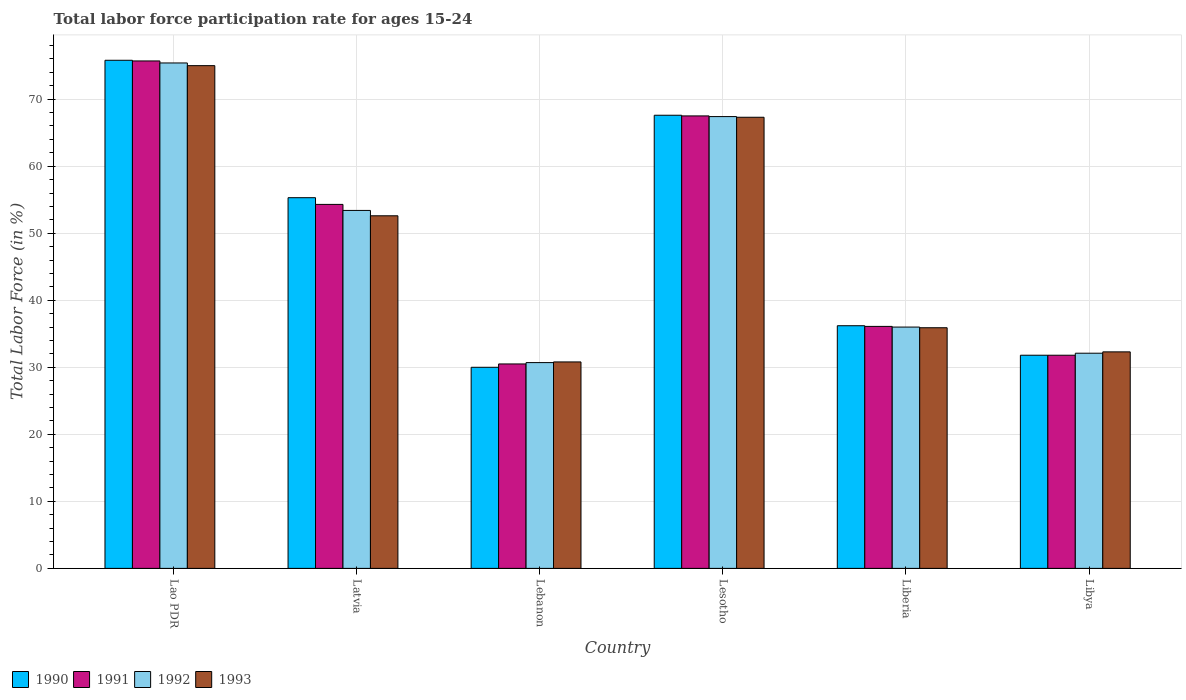Are the number of bars on each tick of the X-axis equal?
Keep it short and to the point. Yes. What is the label of the 6th group of bars from the left?
Offer a terse response. Libya. What is the labor force participation rate in 1992 in Lao PDR?
Give a very brief answer. 75.4. Across all countries, what is the maximum labor force participation rate in 1992?
Give a very brief answer. 75.4. Across all countries, what is the minimum labor force participation rate in 1993?
Give a very brief answer. 30.8. In which country was the labor force participation rate in 1992 maximum?
Keep it short and to the point. Lao PDR. In which country was the labor force participation rate in 1992 minimum?
Offer a very short reply. Lebanon. What is the total labor force participation rate in 1992 in the graph?
Offer a very short reply. 295. What is the difference between the labor force participation rate in 1993 in Lebanon and that in Liberia?
Ensure brevity in your answer.  -5.1. What is the difference between the labor force participation rate in 1993 in Lao PDR and the labor force participation rate in 1990 in Liberia?
Make the answer very short. 38.8. What is the average labor force participation rate in 1993 per country?
Your answer should be compact. 48.98. What is the difference between the labor force participation rate of/in 1992 and labor force participation rate of/in 1991 in Libya?
Your response must be concise. 0.3. What is the ratio of the labor force participation rate in 1991 in Lebanon to that in Liberia?
Your answer should be compact. 0.84. What is the difference between the highest and the second highest labor force participation rate in 1991?
Keep it short and to the point. -8.2. What is the difference between the highest and the lowest labor force participation rate in 1992?
Keep it short and to the point. 44.7. Is the sum of the labor force participation rate in 1992 in Lebanon and Liberia greater than the maximum labor force participation rate in 1993 across all countries?
Offer a very short reply. No. Is it the case that in every country, the sum of the labor force participation rate in 1990 and labor force participation rate in 1992 is greater than the sum of labor force participation rate in 1993 and labor force participation rate in 1991?
Ensure brevity in your answer.  No. What does the 4th bar from the left in Lesotho represents?
Give a very brief answer. 1993. Is it the case that in every country, the sum of the labor force participation rate in 1992 and labor force participation rate in 1991 is greater than the labor force participation rate in 1993?
Ensure brevity in your answer.  Yes. How many bars are there?
Offer a very short reply. 24. How many countries are there in the graph?
Offer a terse response. 6. Does the graph contain any zero values?
Keep it short and to the point. No. Where does the legend appear in the graph?
Your answer should be compact. Bottom left. How are the legend labels stacked?
Give a very brief answer. Horizontal. What is the title of the graph?
Your answer should be very brief. Total labor force participation rate for ages 15-24. What is the Total Labor Force (in %) in 1990 in Lao PDR?
Give a very brief answer. 75.8. What is the Total Labor Force (in %) in 1991 in Lao PDR?
Your response must be concise. 75.7. What is the Total Labor Force (in %) in 1992 in Lao PDR?
Offer a terse response. 75.4. What is the Total Labor Force (in %) in 1993 in Lao PDR?
Your answer should be compact. 75. What is the Total Labor Force (in %) of 1990 in Latvia?
Your response must be concise. 55.3. What is the Total Labor Force (in %) of 1991 in Latvia?
Your response must be concise. 54.3. What is the Total Labor Force (in %) in 1992 in Latvia?
Give a very brief answer. 53.4. What is the Total Labor Force (in %) of 1993 in Latvia?
Ensure brevity in your answer.  52.6. What is the Total Labor Force (in %) of 1991 in Lebanon?
Your answer should be very brief. 30.5. What is the Total Labor Force (in %) in 1992 in Lebanon?
Give a very brief answer. 30.7. What is the Total Labor Force (in %) in 1993 in Lebanon?
Ensure brevity in your answer.  30.8. What is the Total Labor Force (in %) in 1990 in Lesotho?
Provide a succinct answer. 67.6. What is the Total Labor Force (in %) of 1991 in Lesotho?
Your response must be concise. 67.5. What is the Total Labor Force (in %) in 1992 in Lesotho?
Ensure brevity in your answer.  67.4. What is the Total Labor Force (in %) of 1993 in Lesotho?
Offer a very short reply. 67.3. What is the Total Labor Force (in %) of 1990 in Liberia?
Provide a succinct answer. 36.2. What is the Total Labor Force (in %) in 1991 in Liberia?
Ensure brevity in your answer.  36.1. What is the Total Labor Force (in %) in 1993 in Liberia?
Ensure brevity in your answer.  35.9. What is the Total Labor Force (in %) in 1990 in Libya?
Keep it short and to the point. 31.8. What is the Total Labor Force (in %) of 1991 in Libya?
Provide a short and direct response. 31.8. What is the Total Labor Force (in %) of 1992 in Libya?
Provide a short and direct response. 32.1. What is the Total Labor Force (in %) in 1993 in Libya?
Your answer should be compact. 32.3. Across all countries, what is the maximum Total Labor Force (in %) in 1990?
Give a very brief answer. 75.8. Across all countries, what is the maximum Total Labor Force (in %) of 1991?
Provide a short and direct response. 75.7. Across all countries, what is the maximum Total Labor Force (in %) of 1992?
Your answer should be compact. 75.4. Across all countries, what is the minimum Total Labor Force (in %) of 1990?
Keep it short and to the point. 30. Across all countries, what is the minimum Total Labor Force (in %) of 1991?
Your answer should be compact. 30.5. Across all countries, what is the minimum Total Labor Force (in %) in 1992?
Your answer should be very brief. 30.7. Across all countries, what is the minimum Total Labor Force (in %) of 1993?
Provide a succinct answer. 30.8. What is the total Total Labor Force (in %) of 1990 in the graph?
Ensure brevity in your answer.  296.7. What is the total Total Labor Force (in %) in 1991 in the graph?
Keep it short and to the point. 295.9. What is the total Total Labor Force (in %) of 1992 in the graph?
Keep it short and to the point. 295. What is the total Total Labor Force (in %) in 1993 in the graph?
Your response must be concise. 293.9. What is the difference between the Total Labor Force (in %) in 1991 in Lao PDR and that in Latvia?
Offer a terse response. 21.4. What is the difference between the Total Labor Force (in %) in 1993 in Lao PDR and that in Latvia?
Ensure brevity in your answer.  22.4. What is the difference between the Total Labor Force (in %) of 1990 in Lao PDR and that in Lebanon?
Your response must be concise. 45.8. What is the difference between the Total Labor Force (in %) in 1991 in Lao PDR and that in Lebanon?
Ensure brevity in your answer.  45.2. What is the difference between the Total Labor Force (in %) in 1992 in Lao PDR and that in Lebanon?
Give a very brief answer. 44.7. What is the difference between the Total Labor Force (in %) of 1993 in Lao PDR and that in Lebanon?
Give a very brief answer. 44.2. What is the difference between the Total Labor Force (in %) in 1990 in Lao PDR and that in Lesotho?
Offer a very short reply. 8.2. What is the difference between the Total Labor Force (in %) in 1991 in Lao PDR and that in Lesotho?
Keep it short and to the point. 8.2. What is the difference between the Total Labor Force (in %) of 1992 in Lao PDR and that in Lesotho?
Your answer should be very brief. 8. What is the difference between the Total Labor Force (in %) in 1993 in Lao PDR and that in Lesotho?
Offer a terse response. 7.7. What is the difference between the Total Labor Force (in %) of 1990 in Lao PDR and that in Liberia?
Provide a short and direct response. 39.6. What is the difference between the Total Labor Force (in %) in 1991 in Lao PDR and that in Liberia?
Provide a short and direct response. 39.6. What is the difference between the Total Labor Force (in %) of 1992 in Lao PDR and that in Liberia?
Your response must be concise. 39.4. What is the difference between the Total Labor Force (in %) of 1993 in Lao PDR and that in Liberia?
Offer a very short reply. 39.1. What is the difference between the Total Labor Force (in %) of 1991 in Lao PDR and that in Libya?
Your answer should be compact. 43.9. What is the difference between the Total Labor Force (in %) of 1992 in Lao PDR and that in Libya?
Provide a short and direct response. 43.3. What is the difference between the Total Labor Force (in %) in 1993 in Lao PDR and that in Libya?
Provide a succinct answer. 42.7. What is the difference between the Total Labor Force (in %) of 1990 in Latvia and that in Lebanon?
Your answer should be very brief. 25.3. What is the difference between the Total Labor Force (in %) of 1991 in Latvia and that in Lebanon?
Give a very brief answer. 23.8. What is the difference between the Total Labor Force (in %) in 1992 in Latvia and that in Lebanon?
Provide a short and direct response. 22.7. What is the difference between the Total Labor Force (in %) in 1993 in Latvia and that in Lebanon?
Your response must be concise. 21.8. What is the difference between the Total Labor Force (in %) of 1990 in Latvia and that in Lesotho?
Offer a very short reply. -12.3. What is the difference between the Total Labor Force (in %) of 1991 in Latvia and that in Lesotho?
Your response must be concise. -13.2. What is the difference between the Total Labor Force (in %) of 1993 in Latvia and that in Lesotho?
Provide a short and direct response. -14.7. What is the difference between the Total Labor Force (in %) in 1990 in Latvia and that in Liberia?
Your answer should be very brief. 19.1. What is the difference between the Total Labor Force (in %) in 1992 in Latvia and that in Liberia?
Provide a short and direct response. 17.4. What is the difference between the Total Labor Force (in %) of 1993 in Latvia and that in Liberia?
Give a very brief answer. 16.7. What is the difference between the Total Labor Force (in %) of 1991 in Latvia and that in Libya?
Offer a terse response. 22.5. What is the difference between the Total Labor Force (in %) in 1992 in Latvia and that in Libya?
Your answer should be very brief. 21.3. What is the difference between the Total Labor Force (in %) of 1993 in Latvia and that in Libya?
Provide a succinct answer. 20.3. What is the difference between the Total Labor Force (in %) of 1990 in Lebanon and that in Lesotho?
Ensure brevity in your answer.  -37.6. What is the difference between the Total Labor Force (in %) in 1991 in Lebanon and that in Lesotho?
Ensure brevity in your answer.  -37. What is the difference between the Total Labor Force (in %) of 1992 in Lebanon and that in Lesotho?
Your answer should be very brief. -36.7. What is the difference between the Total Labor Force (in %) in 1993 in Lebanon and that in Lesotho?
Ensure brevity in your answer.  -36.5. What is the difference between the Total Labor Force (in %) in 1991 in Lebanon and that in Liberia?
Provide a succinct answer. -5.6. What is the difference between the Total Labor Force (in %) of 1992 in Lebanon and that in Liberia?
Your answer should be very brief. -5.3. What is the difference between the Total Labor Force (in %) in 1990 in Lebanon and that in Libya?
Your response must be concise. -1.8. What is the difference between the Total Labor Force (in %) of 1990 in Lesotho and that in Liberia?
Give a very brief answer. 31.4. What is the difference between the Total Labor Force (in %) in 1991 in Lesotho and that in Liberia?
Provide a short and direct response. 31.4. What is the difference between the Total Labor Force (in %) in 1992 in Lesotho and that in Liberia?
Your answer should be very brief. 31.4. What is the difference between the Total Labor Force (in %) in 1993 in Lesotho and that in Liberia?
Offer a terse response. 31.4. What is the difference between the Total Labor Force (in %) in 1990 in Lesotho and that in Libya?
Your answer should be compact. 35.8. What is the difference between the Total Labor Force (in %) of 1991 in Lesotho and that in Libya?
Provide a succinct answer. 35.7. What is the difference between the Total Labor Force (in %) in 1992 in Lesotho and that in Libya?
Provide a succinct answer. 35.3. What is the difference between the Total Labor Force (in %) of 1993 in Lesotho and that in Libya?
Provide a succinct answer. 35. What is the difference between the Total Labor Force (in %) in 1990 in Lao PDR and the Total Labor Force (in %) in 1991 in Latvia?
Provide a short and direct response. 21.5. What is the difference between the Total Labor Force (in %) in 1990 in Lao PDR and the Total Labor Force (in %) in 1992 in Latvia?
Your answer should be very brief. 22.4. What is the difference between the Total Labor Force (in %) in 1990 in Lao PDR and the Total Labor Force (in %) in 1993 in Latvia?
Keep it short and to the point. 23.2. What is the difference between the Total Labor Force (in %) of 1991 in Lao PDR and the Total Labor Force (in %) of 1992 in Latvia?
Your answer should be very brief. 22.3. What is the difference between the Total Labor Force (in %) of 1991 in Lao PDR and the Total Labor Force (in %) of 1993 in Latvia?
Make the answer very short. 23.1. What is the difference between the Total Labor Force (in %) of 1992 in Lao PDR and the Total Labor Force (in %) of 1993 in Latvia?
Provide a succinct answer. 22.8. What is the difference between the Total Labor Force (in %) of 1990 in Lao PDR and the Total Labor Force (in %) of 1991 in Lebanon?
Provide a short and direct response. 45.3. What is the difference between the Total Labor Force (in %) of 1990 in Lao PDR and the Total Labor Force (in %) of 1992 in Lebanon?
Your response must be concise. 45.1. What is the difference between the Total Labor Force (in %) of 1990 in Lao PDR and the Total Labor Force (in %) of 1993 in Lebanon?
Offer a very short reply. 45. What is the difference between the Total Labor Force (in %) in 1991 in Lao PDR and the Total Labor Force (in %) in 1993 in Lebanon?
Offer a very short reply. 44.9. What is the difference between the Total Labor Force (in %) in 1992 in Lao PDR and the Total Labor Force (in %) in 1993 in Lebanon?
Your answer should be very brief. 44.6. What is the difference between the Total Labor Force (in %) of 1990 in Lao PDR and the Total Labor Force (in %) of 1991 in Lesotho?
Keep it short and to the point. 8.3. What is the difference between the Total Labor Force (in %) of 1991 in Lao PDR and the Total Labor Force (in %) of 1992 in Lesotho?
Keep it short and to the point. 8.3. What is the difference between the Total Labor Force (in %) in 1990 in Lao PDR and the Total Labor Force (in %) in 1991 in Liberia?
Your answer should be compact. 39.7. What is the difference between the Total Labor Force (in %) in 1990 in Lao PDR and the Total Labor Force (in %) in 1992 in Liberia?
Ensure brevity in your answer.  39.8. What is the difference between the Total Labor Force (in %) in 1990 in Lao PDR and the Total Labor Force (in %) in 1993 in Liberia?
Offer a very short reply. 39.9. What is the difference between the Total Labor Force (in %) of 1991 in Lao PDR and the Total Labor Force (in %) of 1992 in Liberia?
Offer a terse response. 39.7. What is the difference between the Total Labor Force (in %) in 1991 in Lao PDR and the Total Labor Force (in %) in 1993 in Liberia?
Give a very brief answer. 39.8. What is the difference between the Total Labor Force (in %) of 1992 in Lao PDR and the Total Labor Force (in %) of 1993 in Liberia?
Your response must be concise. 39.5. What is the difference between the Total Labor Force (in %) of 1990 in Lao PDR and the Total Labor Force (in %) of 1992 in Libya?
Your response must be concise. 43.7. What is the difference between the Total Labor Force (in %) of 1990 in Lao PDR and the Total Labor Force (in %) of 1993 in Libya?
Offer a very short reply. 43.5. What is the difference between the Total Labor Force (in %) of 1991 in Lao PDR and the Total Labor Force (in %) of 1992 in Libya?
Keep it short and to the point. 43.6. What is the difference between the Total Labor Force (in %) in 1991 in Lao PDR and the Total Labor Force (in %) in 1993 in Libya?
Make the answer very short. 43.4. What is the difference between the Total Labor Force (in %) in 1992 in Lao PDR and the Total Labor Force (in %) in 1993 in Libya?
Offer a very short reply. 43.1. What is the difference between the Total Labor Force (in %) of 1990 in Latvia and the Total Labor Force (in %) of 1991 in Lebanon?
Your answer should be very brief. 24.8. What is the difference between the Total Labor Force (in %) of 1990 in Latvia and the Total Labor Force (in %) of 1992 in Lebanon?
Your answer should be compact. 24.6. What is the difference between the Total Labor Force (in %) of 1990 in Latvia and the Total Labor Force (in %) of 1993 in Lebanon?
Give a very brief answer. 24.5. What is the difference between the Total Labor Force (in %) of 1991 in Latvia and the Total Labor Force (in %) of 1992 in Lebanon?
Provide a short and direct response. 23.6. What is the difference between the Total Labor Force (in %) of 1991 in Latvia and the Total Labor Force (in %) of 1993 in Lebanon?
Your answer should be compact. 23.5. What is the difference between the Total Labor Force (in %) in 1992 in Latvia and the Total Labor Force (in %) in 1993 in Lebanon?
Your response must be concise. 22.6. What is the difference between the Total Labor Force (in %) in 1990 in Latvia and the Total Labor Force (in %) in 1991 in Lesotho?
Make the answer very short. -12.2. What is the difference between the Total Labor Force (in %) of 1990 in Latvia and the Total Labor Force (in %) of 1993 in Lesotho?
Keep it short and to the point. -12. What is the difference between the Total Labor Force (in %) of 1991 in Latvia and the Total Labor Force (in %) of 1992 in Lesotho?
Offer a very short reply. -13.1. What is the difference between the Total Labor Force (in %) of 1991 in Latvia and the Total Labor Force (in %) of 1993 in Lesotho?
Offer a terse response. -13. What is the difference between the Total Labor Force (in %) of 1992 in Latvia and the Total Labor Force (in %) of 1993 in Lesotho?
Make the answer very short. -13.9. What is the difference between the Total Labor Force (in %) in 1990 in Latvia and the Total Labor Force (in %) in 1992 in Liberia?
Your response must be concise. 19.3. What is the difference between the Total Labor Force (in %) of 1990 in Latvia and the Total Labor Force (in %) of 1993 in Liberia?
Offer a terse response. 19.4. What is the difference between the Total Labor Force (in %) in 1991 in Latvia and the Total Labor Force (in %) in 1993 in Liberia?
Your answer should be very brief. 18.4. What is the difference between the Total Labor Force (in %) in 1992 in Latvia and the Total Labor Force (in %) in 1993 in Liberia?
Offer a terse response. 17.5. What is the difference between the Total Labor Force (in %) in 1990 in Latvia and the Total Labor Force (in %) in 1991 in Libya?
Your answer should be compact. 23.5. What is the difference between the Total Labor Force (in %) in 1990 in Latvia and the Total Labor Force (in %) in 1992 in Libya?
Ensure brevity in your answer.  23.2. What is the difference between the Total Labor Force (in %) in 1990 in Latvia and the Total Labor Force (in %) in 1993 in Libya?
Give a very brief answer. 23. What is the difference between the Total Labor Force (in %) in 1991 in Latvia and the Total Labor Force (in %) in 1993 in Libya?
Your answer should be compact. 22. What is the difference between the Total Labor Force (in %) in 1992 in Latvia and the Total Labor Force (in %) in 1993 in Libya?
Your answer should be compact. 21.1. What is the difference between the Total Labor Force (in %) in 1990 in Lebanon and the Total Labor Force (in %) in 1991 in Lesotho?
Make the answer very short. -37.5. What is the difference between the Total Labor Force (in %) of 1990 in Lebanon and the Total Labor Force (in %) of 1992 in Lesotho?
Your response must be concise. -37.4. What is the difference between the Total Labor Force (in %) of 1990 in Lebanon and the Total Labor Force (in %) of 1993 in Lesotho?
Keep it short and to the point. -37.3. What is the difference between the Total Labor Force (in %) in 1991 in Lebanon and the Total Labor Force (in %) in 1992 in Lesotho?
Offer a very short reply. -36.9. What is the difference between the Total Labor Force (in %) of 1991 in Lebanon and the Total Labor Force (in %) of 1993 in Lesotho?
Offer a terse response. -36.8. What is the difference between the Total Labor Force (in %) of 1992 in Lebanon and the Total Labor Force (in %) of 1993 in Lesotho?
Your response must be concise. -36.6. What is the difference between the Total Labor Force (in %) in 1991 in Lebanon and the Total Labor Force (in %) in 1993 in Libya?
Give a very brief answer. -1.8. What is the difference between the Total Labor Force (in %) of 1992 in Lebanon and the Total Labor Force (in %) of 1993 in Libya?
Provide a succinct answer. -1.6. What is the difference between the Total Labor Force (in %) in 1990 in Lesotho and the Total Labor Force (in %) in 1991 in Liberia?
Provide a succinct answer. 31.5. What is the difference between the Total Labor Force (in %) in 1990 in Lesotho and the Total Labor Force (in %) in 1992 in Liberia?
Give a very brief answer. 31.6. What is the difference between the Total Labor Force (in %) in 1990 in Lesotho and the Total Labor Force (in %) in 1993 in Liberia?
Provide a short and direct response. 31.7. What is the difference between the Total Labor Force (in %) in 1991 in Lesotho and the Total Labor Force (in %) in 1992 in Liberia?
Give a very brief answer. 31.5. What is the difference between the Total Labor Force (in %) of 1991 in Lesotho and the Total Labor Force (in %) of 1993 in Liberia?
Your answer should be very brief. 31.6. What is the difference between the Total Labor Force (in %) in 1992 in Lesotho and the Total Labor Force (in %) in 1993 in Liberia?
Your answer should be very brief. 31.5. What is the difference between the Total Labor Force (in %) in 1990 in Lesotho and the Total Labor Force (in %) in 1991 in Libya?
Your answer should be very brief. 35.8. What is the difference between the Total Labor Force (in %) of 1990 in Lesotho and the Total Labor Force (in %) of 1992 in Libya?
Ensure brevity in your answer.  35.5. What is the difference between the Total Labor Force (in %) in 1990 in Lesotho and the Total Labor Force (in %) in 1993 in Libya?
Ensure brevity in your answer.  35.3. What is the difference between the Total Labor Force (in %) in 1991 in Lesotho and the Total Labor Force (in %) in 1992 in Libya?
Your response must be concise. 35.4. What is the difference between the Total Labor Force (in %) in 1991 in Lesotho and the Total Labor Force (in %) in 1993 in Libya?
Your answer should be very brief. 35.2. What is the difference between the Total Labor Force (in %) of 1992 in Lesotho and the Total Labor Force (in %) of 1993 in Libya?
Provide a short and direct response. 35.1. What is the difference between the Total Labor Force (in %) of 1990 in Liberia and the Total Labor Force (in %) of 1991 in Libya?
Provide a succinct answer. 4.4. What is the difference between the Total Labor Force (in %) of 1991 in Liberia and the Total Labor Force (in %) of 1993 in Libya?
Your answer should be very brief. 3.8. What is the difference between the Total Labor Force (in %) in 1992 in Liberia and the Total Labor Force (in %) in 1993 in Libya?
Your response must be concise. 3.7. What is the average Total Labor Force (in %) of 1990 per country?
Your answer should be very brief. 49.45. What is the average Total Labor Force (in %) in 1991 per country?
Your response must be concise. 49.32. What is the average Total Labor Force (in %) in 1992 per country?
Keep it short and to the point. 49.17. What is the average Total Labor Force (in %) in 1993 per country?
Ensure brevity in your answer.  48.98. What is the difference between the Total Labor Force (in %) in 1990 and Total Labor Force (in %) in 1991 in Lao PDR?
Ensure brevity in your answer.  0.1. What is the difference between the Total Labor Force (in %) of 1990 and Total Labor Force (in %) of 1993 in Lao PDR?
Your answer should be compact. 0.8. What is the difference between the Total Labor Force (in %) in 1991 and Total Labor Force (in %) in 1992 in Lao PDR?
Offer a very short reply. 0.3. What is the difference between the Total Labor Force (in %) of 1992 and Total Labor Force (in %) of 1993 in Lao PDR?
Make the answer very short. 0.4. What is the difference between the Total Labor Force (in %) in 1990 and Total Labor Force (in %) in 1992 in Latvia?
Your response must be concise. 1.9. What is the difference between the Total Labor Force (in %) of 1990 and Total Labor Force (in %) of 1993 in Latvia?
Your answer should be very brief. 2.7. What is the difference between the Total Labor Force (in %) in 1991 and Total Labor Force (in %) in 1992 in Latvia?
Provide a succinct answer. 0.9. What is the difference between the Total Labor Force (in %) in 1991 and Total Labor Force (in %) in 1993 in Latvia?
Offer a very short reply. 1.7. What is the difference between the Total Labor Force (in %) in 1992 and Total Labor Force (in %) in 1993 in Latvia?
Your answer should be very brief. 0.8. What is the difference between the Total Labor Force (in %) in 1990 and Total Labor Force (in %) in 1992 in Lebanon?
Give a very brief answer. -0.7. What is the difference between the Total Labor Force (in %) of 1990 and Total Labor Force (in %) of 1993 in Lebanon?
Give a very brief answer. -0.8. What is the difference between the Total Labor Force (in %) in 1991 and Total Labor Force (in %) in 1993 in Lebanon?
Keep it short and to the point. -0.3. What is the difference between the Total Labor Force (in %) in 1992 and Total Labor Force (in %) in 1993 in Lebanon?
Your response must be concise. -0.1. What is the difference between the Total Labor Force (in %) in 1990 and Total Labor Force (in %) in 1991 in Lesotho?
Your answer should be compact. 0.1. What is the difference between the Total Labor Force (in %) in 1990 and Total Labor Force (in %) in 1992 in Lesotho?
Your answer should be very brief. 0.2. What is the difference between the Total Labor Force (in %) in 1991 and Total Labor Force (in %) in 1992 in Lesotho?
Your answer should be compact. 0.1. What is the difference between the Total Labor Force (in %) of 1992 and Total Labor Force (in %) of 1993 in Lesotho?
Your answer should be compact. 0.1. What is the difference between the Total Labor Force (in %) of 1991 and Total Labor Force (in %) of 1992 in Liberia?
Ensure brevity in your answer.  0.1. What is the difference between the Total Labor Force (in %) in 1992 and Total Labor Force (in %) in 1993 in Liberia?
Give a very brief answer. 0.1. What is the difference between the Total Labor Force (in %) of 1991 and Total Labor Force (in %) of 1993 in Libya?
Give a very brief answer. -0.5. What is the ratio of the Total Labor Force (in %) in 1990 in Lao PDR to that in Latvia?
Give a very brief answer. 1.37. What is the ratio of the Total Labor Force (in %) in 1991 in Lao PDR to that in Latvia?
Keep it short and to the point. 1.39. What is the ratio of the Total Labor Force (in %) of 1992 in Lao PDR to that in Latvia?
Your answer should be compact. 1.41. What is the ratio of the Total Labor Force (in %) in 1993 in Lao PDR to that in Latvia?
Your response must be concise. 1.43. What is the ratio of the Total Labor Force (in %) of 1990 in Lao PDR to that in Lebanon?
Keep it short and to the point. 2.53. What is the ratio of the Total Labor Force (in %) in 1991 in Lao PDR to that in Lebanon?
Make the answer very short. 2.48. What is the ratio of the Total Labor Force (in %) of 1992 in Lao PDR to that in Lebanon?
Your answer should be compact. 2.46. What is the ratio of the Total Labor Force (in %) in 1993 in Lao PDR to that in Lebanon?
Make the answer very short. 2.44. What is the ratio of the Total Labor Force (in %) in 1990 in Lao PDR to that in Lesotho?
Offer a very short reply. 1.12. What is the ratio of the Total Labor Force (in %) in 1991 in Lao PDR to that in Lesotho?
Your response must be concise. 1.12. What is the ratio of the Total Labor Force (in %) in 1992 in Lao PDR to that in Lesotho?
Provide a succinct answer. 1.12. What is the ratio of the Total Labor Force (in %) in 1993 in Lao PDR to that in Lesotho?
Provide a succinct answer. 1.11. What is the ratio of the Total Labor Force (in %) of 1990 in Lao PDR to that in Liberia?
Offer a terse response. 2.09. What is the ratio of the Total Labor Force (in %) in 1991 in Lao PDR to that in Liberia?
Offer a terse response. 2.1. What is the ratio of the Total Labor Force (in %) in 1992 in Lao PDR to that in Liberia?
Give a very brief answer. 2.09. What is the ratio of the Total Labor Force (in %) in 1993 in Lao PDR to that in Liberia?
Ensure brevity in your answer.  2.09. What is the ratio of the Total Labor Force (in %) in 1990 in Lao PDR to that in Libya?
Your answer should be compact. 2.38. What is the ratio of the Total Labor Force (in %) in 1991 in Lao PDR to that in Libya?
Offer a very short reply. 2.38. What is the ratio of the Total Labor Force (in %) of 1992 in Lao PDR to that in Libya?
Make the answer very short. 2.35. What is the ratio of the Total Labor Force (in %) in 1993 in Lao PDR to that in Libya?
Your answer should be very brief. 2.32. What is the ratio of the Total Labor Force (in %) of 1990 in Latvia to that in Lebanon?
Your answer should be very brief. 1.84. What is the ratio of the Total Labor Force (in %) of 1991 in Latvia to that in Lebanon?
Give a very brief answer. 1.78. What is the ratio of the Total Labor Force (in %) in 1992 in Latvia to that in Lebanon?
Keep it short and to the point. 1.74. What is the ratio of the Total Labor Force (in %) of 1993 in Latvia to that in Lebanon?
Offer a terse response. 1.71. What is the ratio of the Total Labor Force (in %) of 1990 in Latvia to that in Lesotho?
Provide a succinct answer. 0.82. What is the ratio of the Total Labor Force (in %) in 1991 in Latvia to that in Lesotho?
Offer a very short reply. 0.8. What is the ratio of the Total Labor Force (in %) of 1992 in Latvia to that in Lesotho?
Provide a short and direct response. 0.79. What is the ratio of the Total Labor Force (in %) of 1993 in Latvia to that in Lesotho?
Give a very brief answer. 0.78. What is the ratio of the Total Labor Force (in %) in 1990 in Latvia to that in Liberia?
Keep it short and to the point. 1.53. What is the ratio of the Total Labor Force (in %) of 1991 in Latvia to that in Liberia?
Your answer should be compact. 1.5. What is the ratio of the Total Labor Force (in %) in 1992 in Latvia to that in Liberia?
Make the answer very short. 1.48. What is the ratio of the Total Labor Force (in %) in 1993 in Latvia to that in Liberia?
Your answer should be very brief. 1.47. What is the ratio of the Total Labor Force (in %) in 1990 in Latvia to that in Libya?
Keep it short and to the point. 1.74. What is the ratio of the Total Labor Force (in %) of 1991 in Latvia to that in Libya?
Give a very brief answer. 1.71. What is the ratio of the Total Labor Force (in %) of 1992 in Latvia to that in Libya?
Your response must be concise. 1.66. What is the ratio of the Total Labor Force (in %) in 1993 in Latvia to that in Libya?
Your answer should be compact. 1.63. What is the ratio of the Total Labor Force (in %) in 1990 in Lebanon to that in Lesotho?
Provide a short and direct response. 0.44. What is the ratio of the Total Labor Force (in %) of 1991 in Lebanon to that in Lesotho?
Provide a succinct answer. 0.45. What is the ratio of the Total Labor Force (in %) in 1992 in Lebanon to that in Lesotho?
Make the answer very short. 0.46. What is the ratio of the Total Labor Force (in %) of 1993 in Lebanon to that in Lesotho?
Your response must be concise. 0.46. What is the ratio of the Total Labor Force (in %) of 1990 in Lebanon to that in Liberia?
Keep it short and to the point. 0.83. What is the ratio of the Total Labor Force (in %) of 1991 in Lebanon to that in Liberia?
Provide a short and direct response. 0.84. What is the ratio of the Total Labor Force (in %) in 1992 in Lebanon to that in Liberia?
Your response must be concise. 0.85. What is the ratio of the Total Labor Force (in %) in 1993 in Lebanon to that in Liberia?
Offer a very short reply. 0.86. What is the ratio of the Total Labor Force (in %) in 1990 in Lebanon to that in Libya?
Ensure brevity in your answer.  0.94. What is the ratio of the Total Labor Force (in %) of 1991 in Lebanon to that in Libya?
Give a very brief answer. 0.96. What is the ratio of the Total Labor Force (in %) of 1992 in Lebanon to that in Libya?
Make the answer very short. 0.96. What is the ratio of the Total Labor Force (in %) of 1993 in Lebanon to that in Libya?
Make the answer very short. 0.95. What is the ratio of the Total Labor Force (in %) of 1990 in Lesotho to that in Liberia?
Ensure brevity in your answer.  1.87. What is the ratio of the Total Labor Force (in %) of 1991 in Lesotho to that in Liberia?
Your answer should be compact. 1.87. What is the ratio of the Total Labor Force (in %) of 1992 in Lesotho to that in Liberia?
Offer a very short reply. 1.87. What is the ratio of the Total Labor Force (in %) of 1993 in Lesotho to that in Liberia?
Your answer should be compact. 1.87. What is the ratio of the Total Labor Force (in %) of 1990 in Lesotho to that in Libya?
Your answer should be compact. 2.13. What is the ratio of the Total Labor Force (in %) in 1991 in Lesotho to that in Libya?
Your answer should be very brief. 2.12. What is the ratio of the Total Labor Force (in %) of 1992 in Lesotho to that in Libya?
Provide a succinct answer. 2.1. What is the ratio of the Total Labor Force (in %) in 1993 in Lesotho to that in Libya?
Offer a terse response. 2.08. What is the ratio of the Total Labor Force (in %) in 1990 in Liberia to that in Libya?
Provide a succinct answer. 1.14. What is the ratio of the Total Labor Force (in %) in 1991 in Liberia to that in Libya?
Give a very brief answer. 1.14. What is the ratio of the Total Labor Force (in %) of 1992 in Liberia to that in Libya?
Your answer should be compact. 1.12. What is the ratio of the Total Labor Force (in %) of 1993 in Liberia to that in Libya?
Provide a short and direct response. 1.11. What is the difference between the highest and the second highest Total Labor Force (in %) in 1990?
Provide a short and direct response. 8.2. What is the difference between the highest and the second highest Total Labor Force (in %) in 1991?
Offer a terse response. 8.2. What is the difference between the highest and the second highest Total Labor Force (in %) of 1992?
Offer a very short reply. 8. What is the difference between the highest and the lowest Total Labor Force (in %) in 1990?
Your answer should be very brief. 45.8. What is the difference between the highest and the lowest Total Labor Force (in %) in 1991?
Make the answer very short. 45.2. What is the difference between the highest and the lowest Total Labor Force (in %) of 1992?
Ensure brevity in your answer.  44.7. What is the difference between the highest and the lowest Total Labor Force (in %) in 1993?
Ensure brevity in your answer.  44.2. 